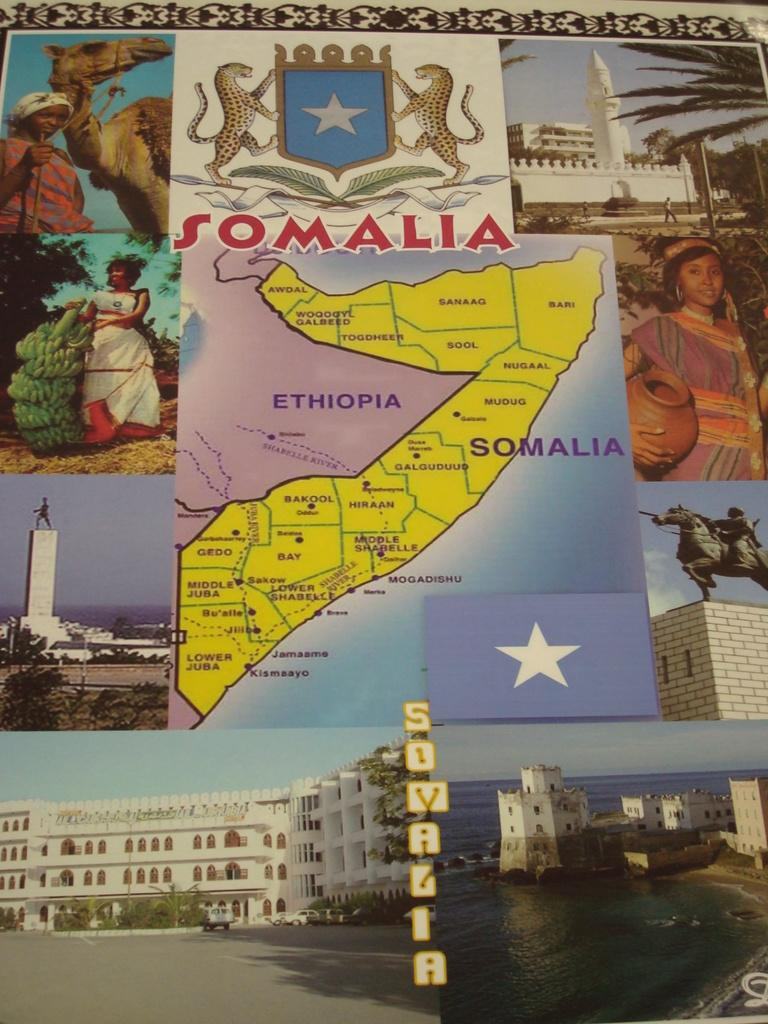<image>
Give a short and clear explanation of the subsequent image. A map displays all of the different individual states in the country of Somalia. 